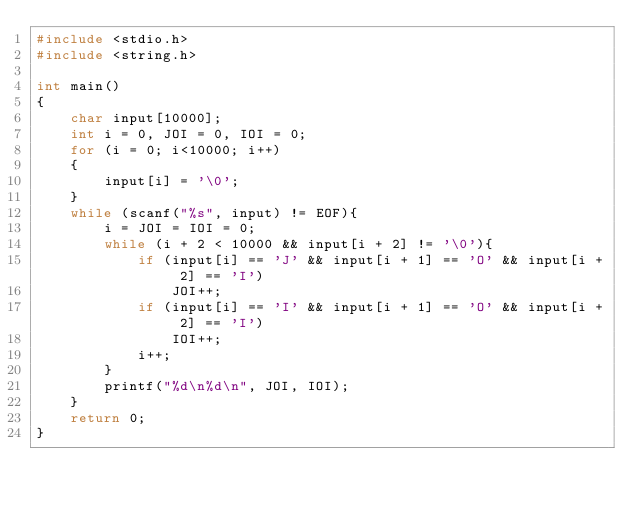Convert code to text. <code><loc_0><loc_0><loc_500><loc_500><_C_>#include <stdio.h>
#include <string.h>

int main()
{
	char input[10000];
	int i = 0, JOI = 0, IOI = 0;
	for (i = 0; i<10000; i++)
	{
		input[i] = '\0';
	}
	while (scanf("%s", input) != EOF){
		i = JOI = IOI = 0;
		while (i + 2 < 10000 && input[i + 2] != '\0'){
			if (input[i] == 'J' && input[i + 1] == 'O' && input[i + 2] == 'I')
				JOI++;
			if (input[i] == 'I' && input[i + 1] == 'O' && input[i + 2] == 'I')
				IOI++;
			i++;
		}
		printf("%d\n%d\n", JOI, IOI);
	}
	return 0;
}</code> 